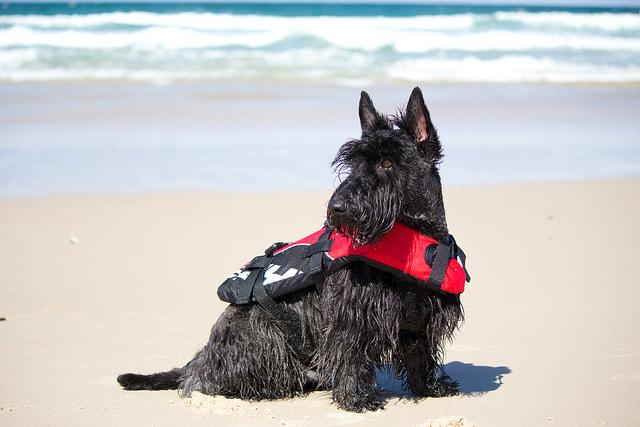Is this dog having a fun day at the beach?
Concise answer only. Yes. What do kilts have in common with this dog?
Answer briefly. Scottish. Is this a large dog?
Concise answer only. No. 